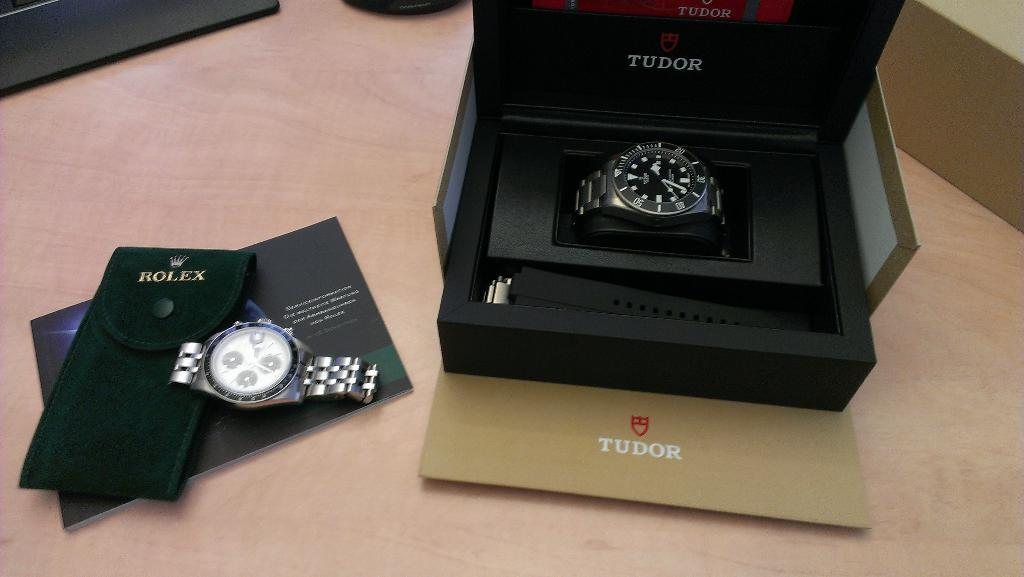Provide a one-sentence caption for the provided image. Black watch in a box which says TUDOR on it. 